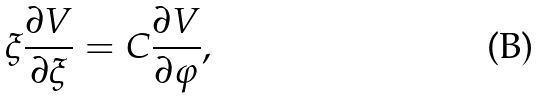Convert formula to latex. <formula><loc_0><loc_0><loc_500><loc_500>\xi \frac { \partial V } { \partial \xi } = C \frac { \partial V } { \partial \varphi } ,</formula> 